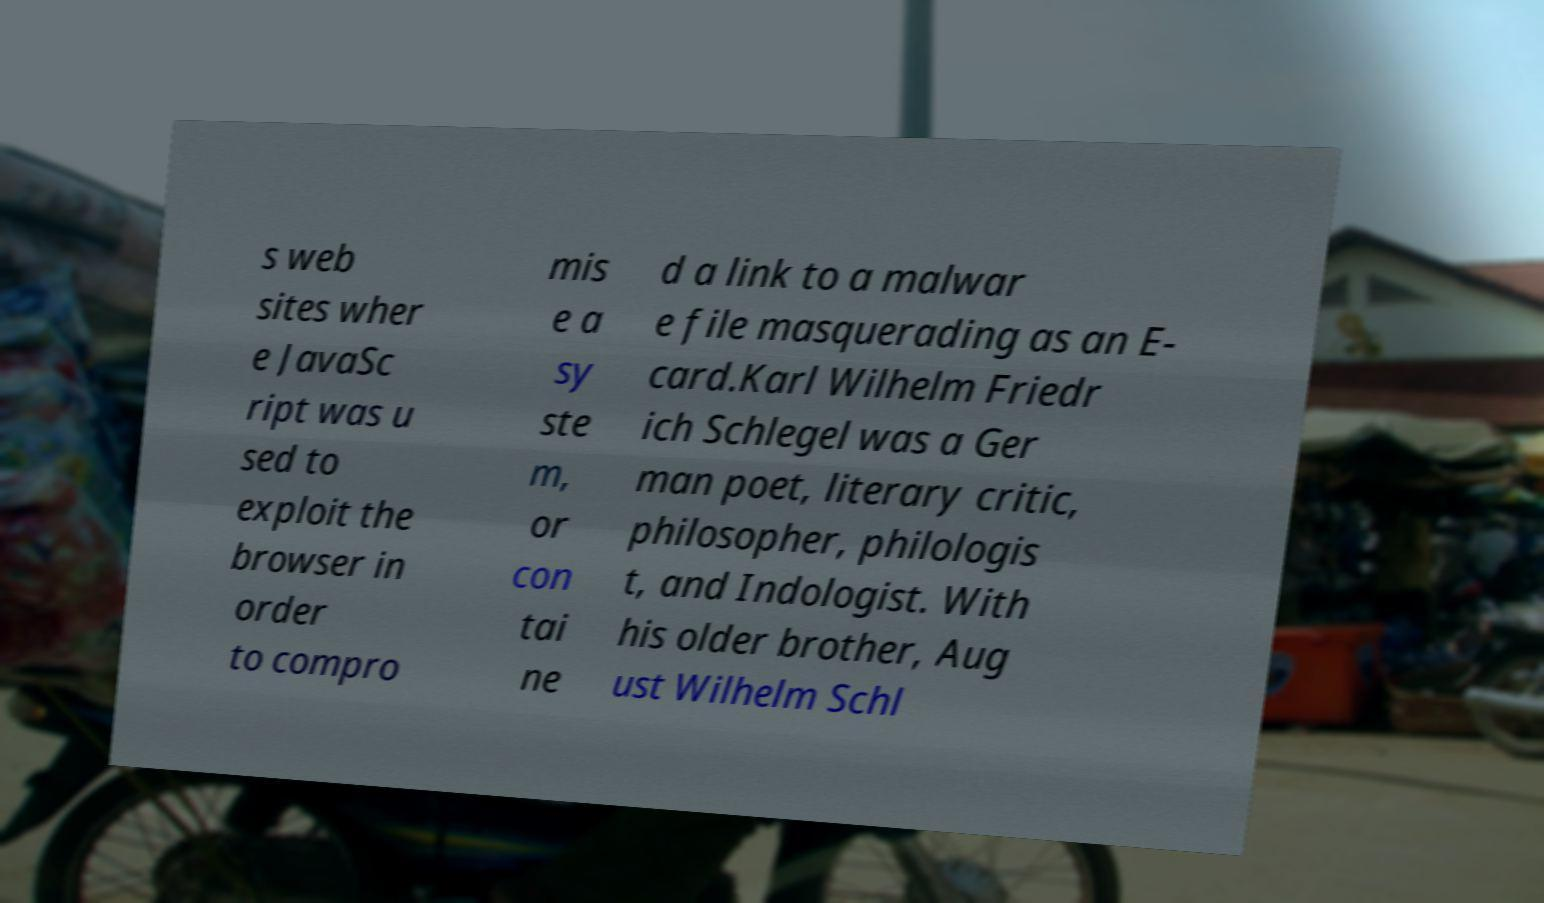Please identify and transcribe the text found in this image. s web sites wher e JavaSc ript was u sed to exploit the browser in order to compro mis e a sy ste m, or con tai ne d a link to a malwar e file masquerading as an E- card.Karl Wilhelm Friedr ich Schlegel was a Ger man poet, literary critic, philosopher, philologis t, and Indologist. With his older brother, Aug ust Wilhelm Schl 